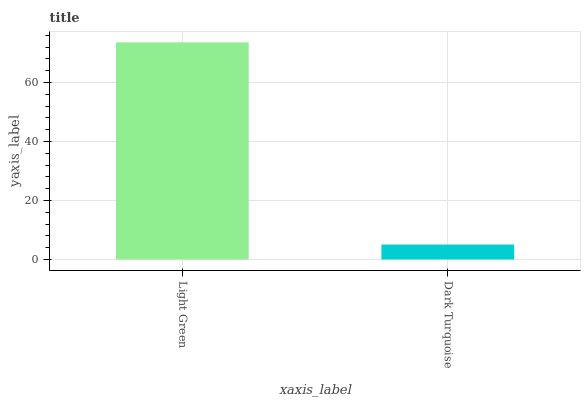Is Dark Turquoise the minimum?
Answer yes or no. Yes. Is Light Green the maximum?
Answer yes or no. Yes. Is Dark Turquoise the maximum?
Answer yes or no. No. Is Light Green greater than Dark Turquoise?
Answer yes or no. Yes. Is Dark Turquoise less than Light Green?
Answer yes or no. Yes. Is Dark Turquoise greater than Light Green?
Answer yes or no. No. Is Light Green less than Dark Turquoise?
Answer yes or no. No. Is Light Green the high median?
Answer yes or no. Yes. Is Dark Turquoise the low median?
Answer yes or no. Yes. Is Dark Turquoise the high median?
Answer yes or no. No. Is Light Green the low median?
Answer yes or no. No. 